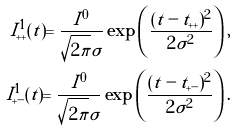<formula> <loc_0><loc_0><loc_500><loc_500>I ^ { 1 } _ { + + } ( t ) = \frac { I ^ { 0 } } { \sqrt { 2 \pi } \sigma } \exp \left ( \frac { ( t - t _ { + + } ) ^ { 2 } } { 2 { \sigma } ^ { 2 } } \right ) , \\ I ^ { 1 } _ { + - } ( t ) = \frac { I ^ { 0 } } { \sqrt { 2 \pi } \sigma } \exp \left ( \frac { ( t - t _ { + - } ) ^ { 2 } } { 2 { \sigma } ^ { 2 } } \right ) .</formula> 